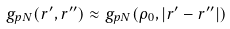Convert formula to latex. <formula><loc_0><loc_0><loc_500><loc_500>g _ { p N } ( { r } ^ { \prime } , { r } ^ { \prime \prime } ) \approx g _ { p N } ( \rho _ { 0 } , | { r } ^ { \prime } - { r } ^ { \prime \prime } | )</formula> 